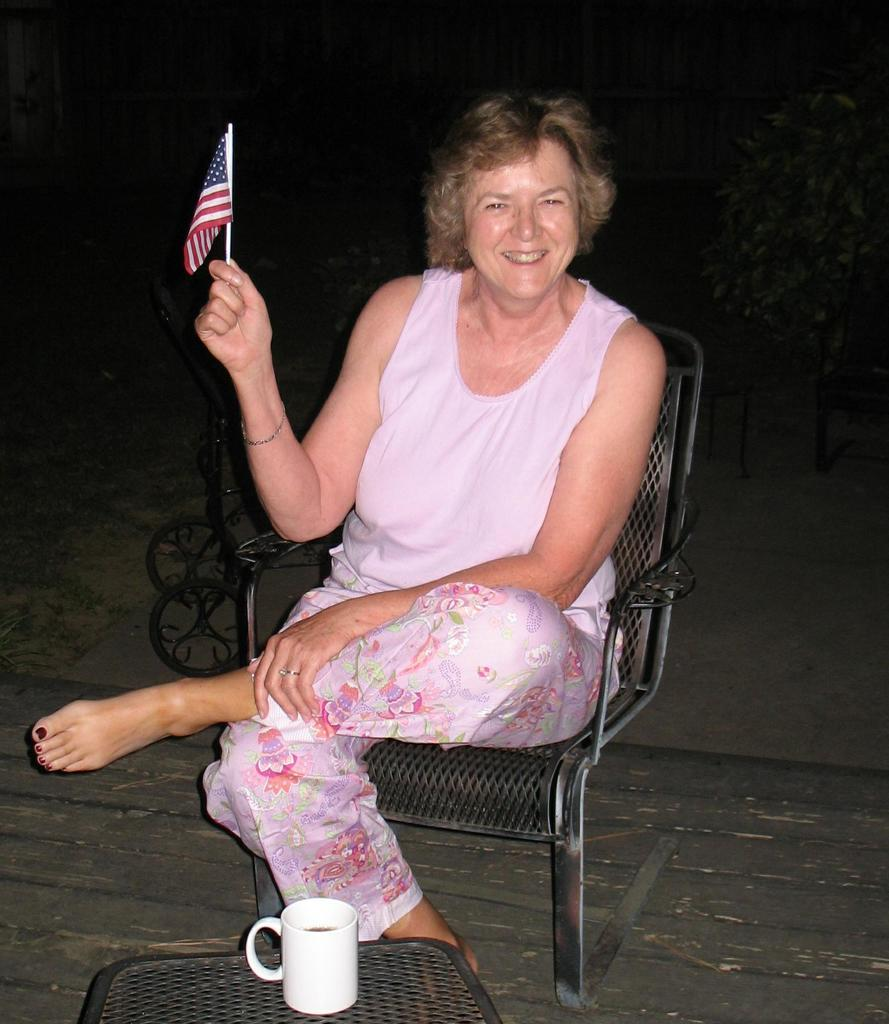What is the woman in the image doing? The woman is sitting on a chair in the image. What is the woman holding in the image? The woman is holding an American flag in the image. What can be seen in the background of the image? There are plants visible in the image. What is on the table in the image? There is a coffee mug on a table in the image. What type of pie is being served on the table in the image? There is no pie present in the image; it features a woman sitting on a chair holding an American flag, plants in the background, and a coffee mug on a table. What type of trousers is the woman wearing in the image? The image does not show the woman's trousers, so it cannot be determined from the image. 